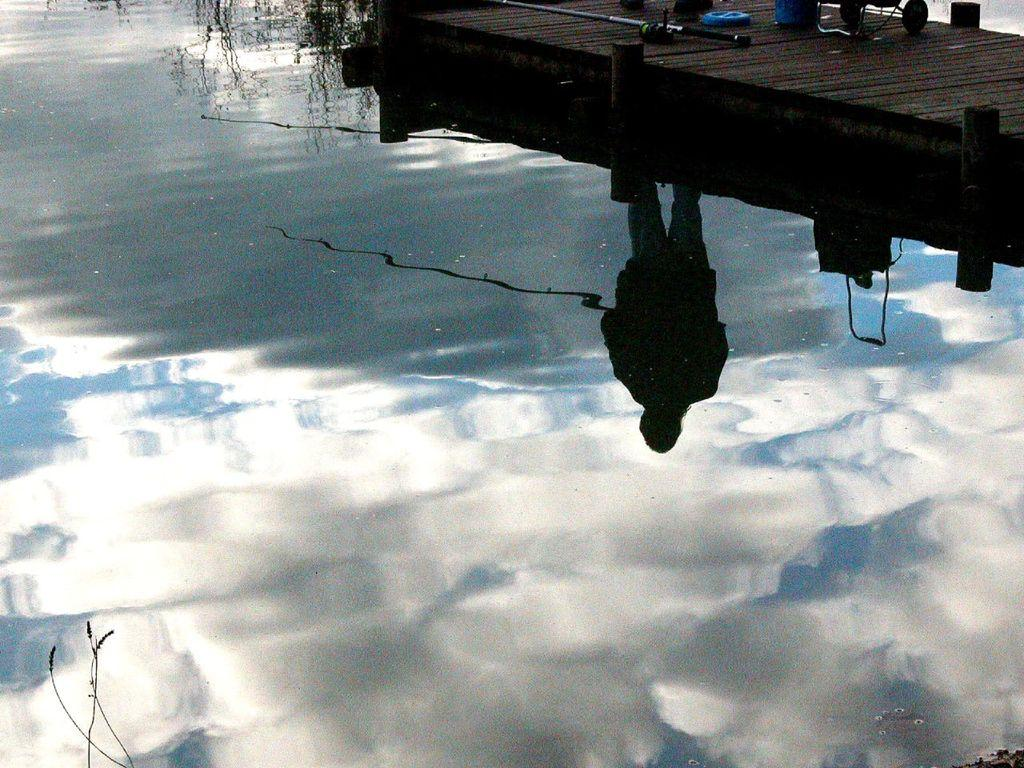What is the main feature in the foreground of the picture? There is a water body in the foreground of the picture. What structure can be seen at the top of the image? There is a dock at the top of the image. What fishing equipment is present on the dock? Fishing needles are present on the dock. What type of vehicle is associated with the dock? Wheels of a vehicle are visible on the dock. What part of a person can be seen on the dock? There are person's legs on the dock. What other objects are present on the dock? Other objects are present on the dock. What type of son can be heard in the background of the image? There is no sound or son present in the image, as it is a still picture. 